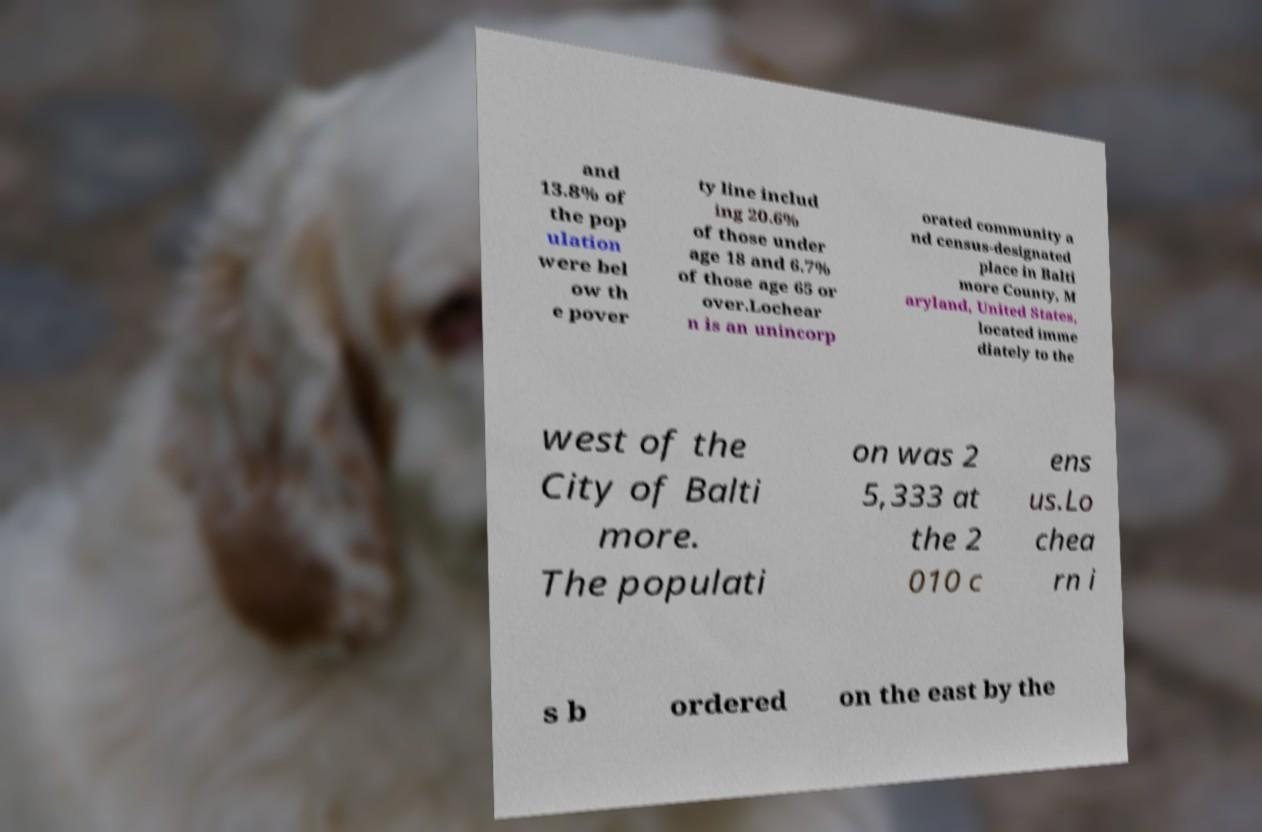Could you assist in decoding the text presented in this image and type it out clearly? and 13.8% of the pop ulation were bel ow th e pover ty line includ ing 20.6% of those under age 18 and 6.7% of those age 65 or over.Lochear n is an unincorp orated community a nd census-designated place in Balti more County, M aryland, United States, located imme diately to the west of the City of Balti more. The populati on was 2 5,333 at the 2 010 c ens us.Lo chea rn i s b ordered on the east by the 